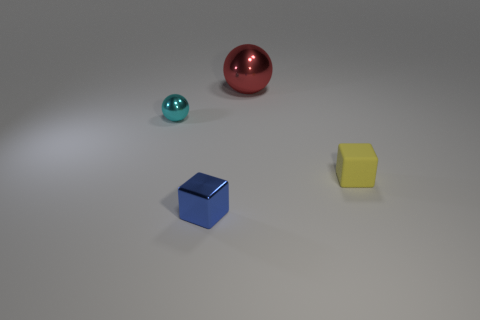Add 4 big yellow rubber blocks. How many objects exist? 8 Add 2 red rubber things. How many red rubber things exist? 2 Subtract 0 purple cylinders. How many objects are left? 4 Subtract all big metallic objects. Subtract all small blue shiny blocks. How many objects are left? 2 Add 1 cyan spheres. How many cyan spheres are left? 2 